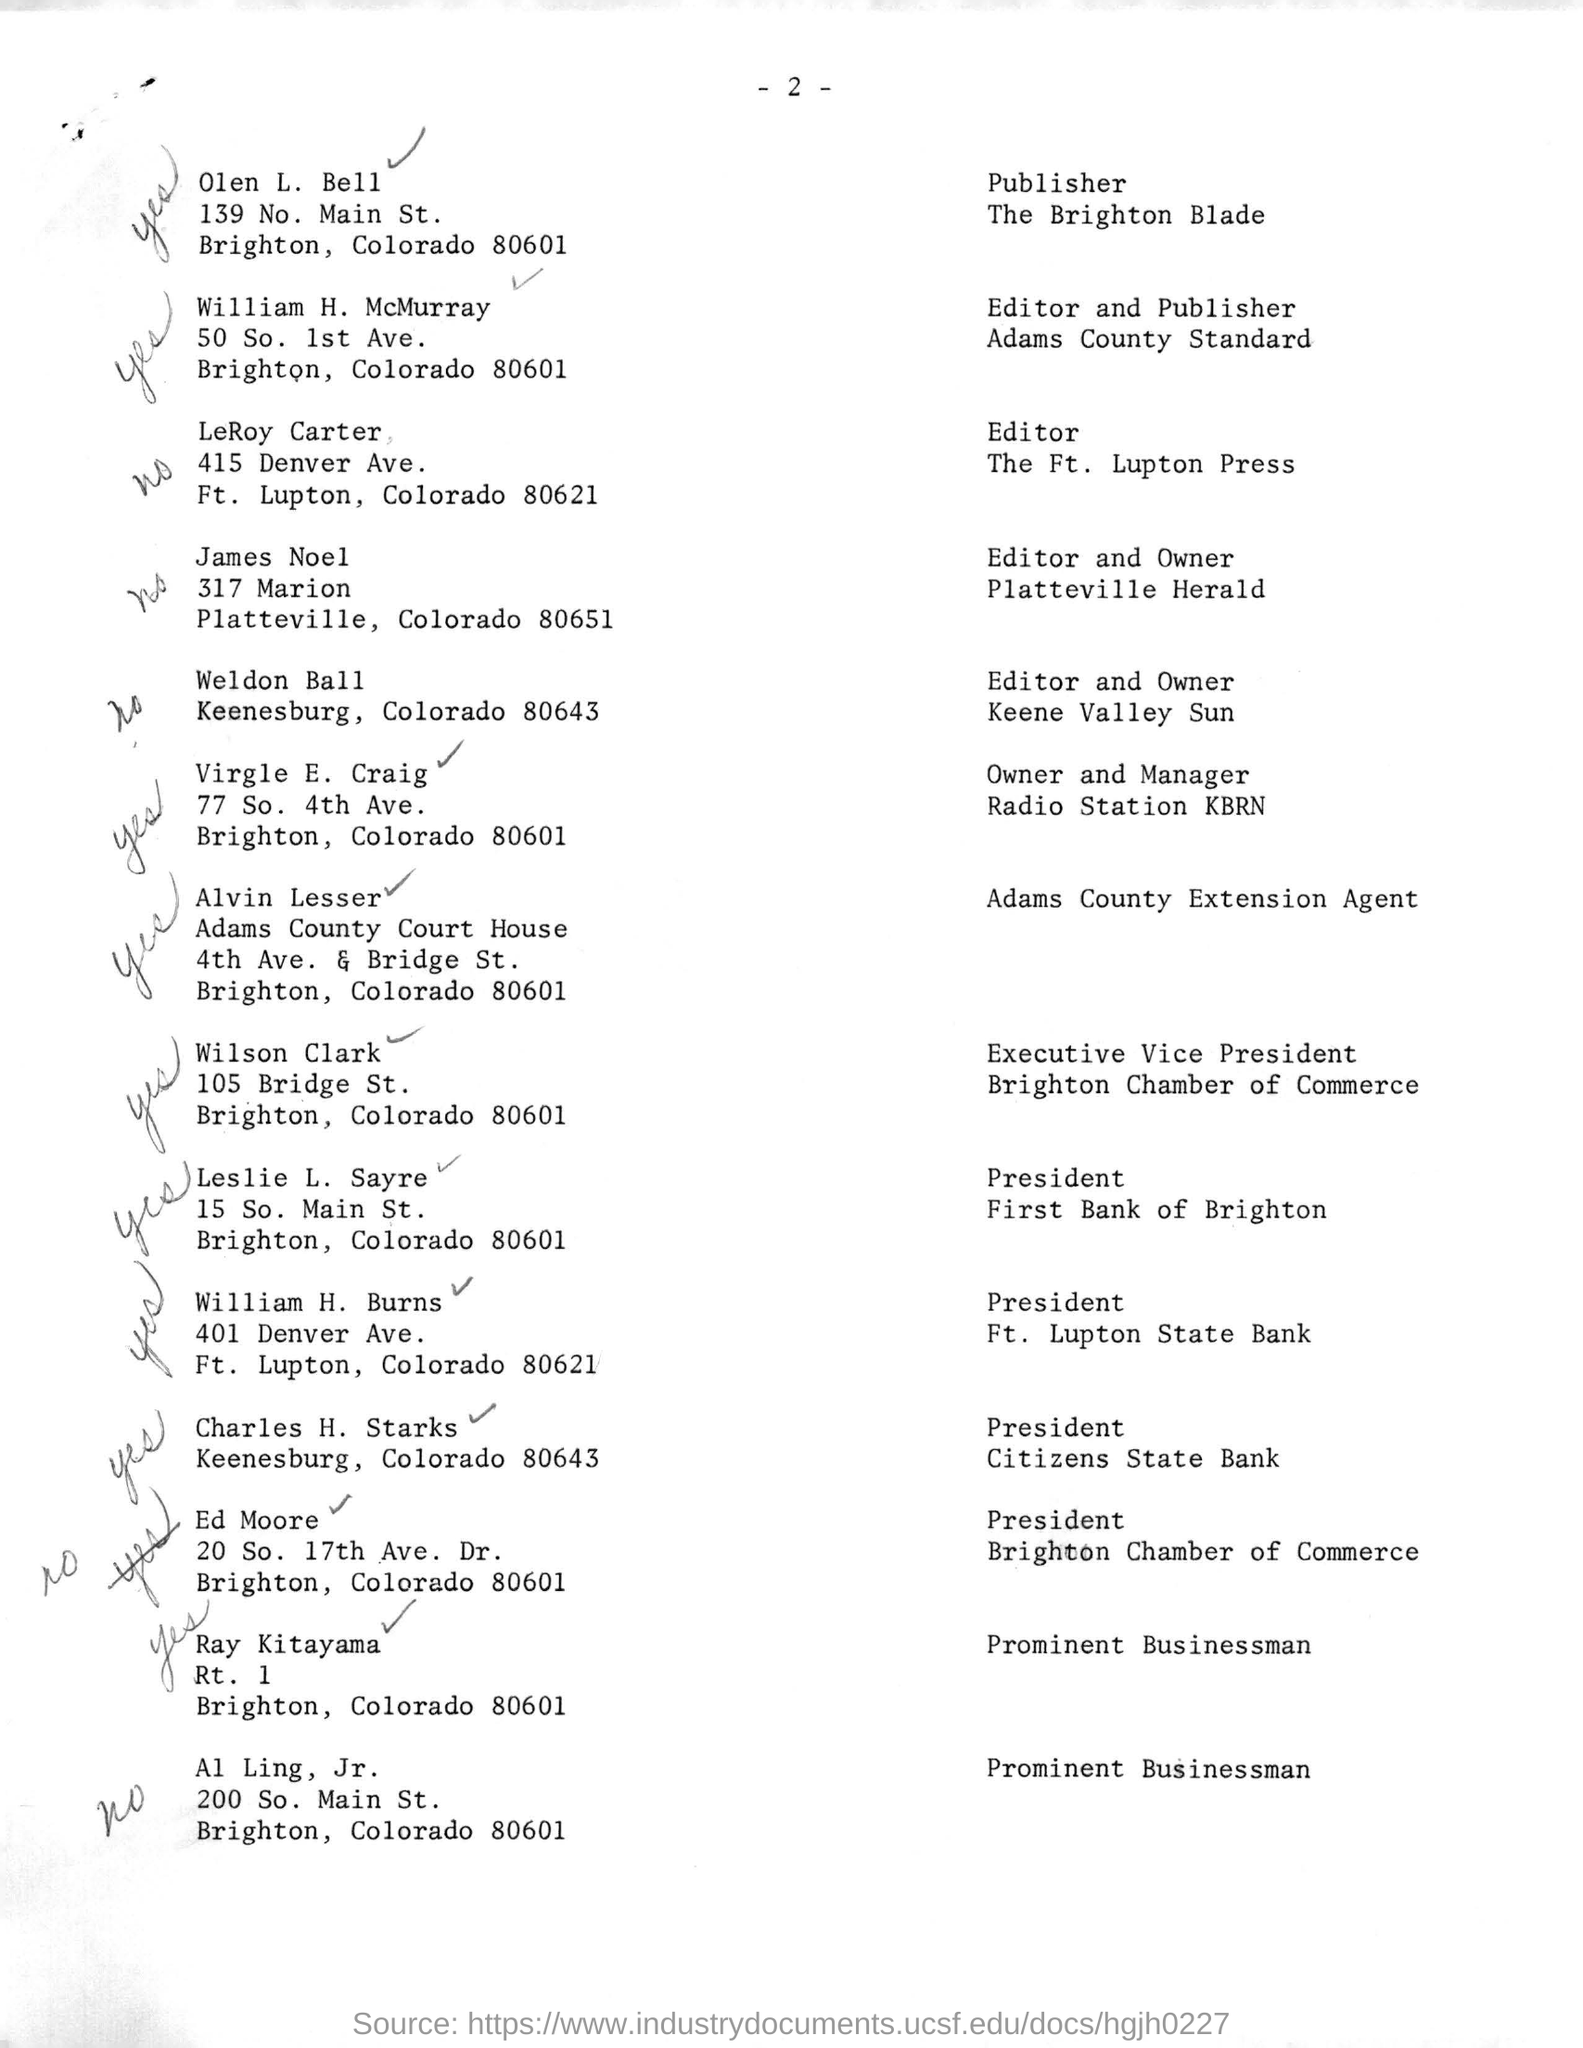Specify some key components in this picture. The page number mentioned in this document is 2. 